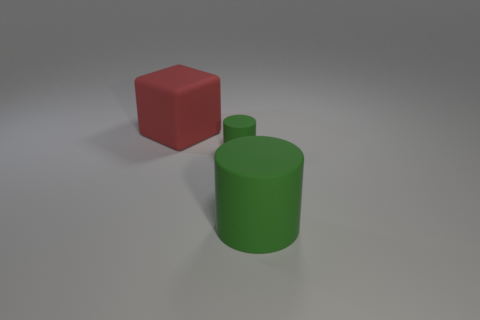Subtract all blocks. How many objects are left? 2 Add 1 cyan metal spheres. How many objects exist? 4 Subtract 0 cyan spheres. How many objects are left? 3 Subtract 1 cubes. How many cubes are left? 0 Subtract all green cubes. Subtract all green balls. How many cubes are left? 1 Subtract all blue balls. How many yellow cylinders are left? 0 Subtract all tiny purple matte objects. Subtract all small matte cylinders. How many objects are left? 2 Add 1 big green objects. How many big green objects are left? 2 Add 1 big red objects. How many big red objects exist? 2 